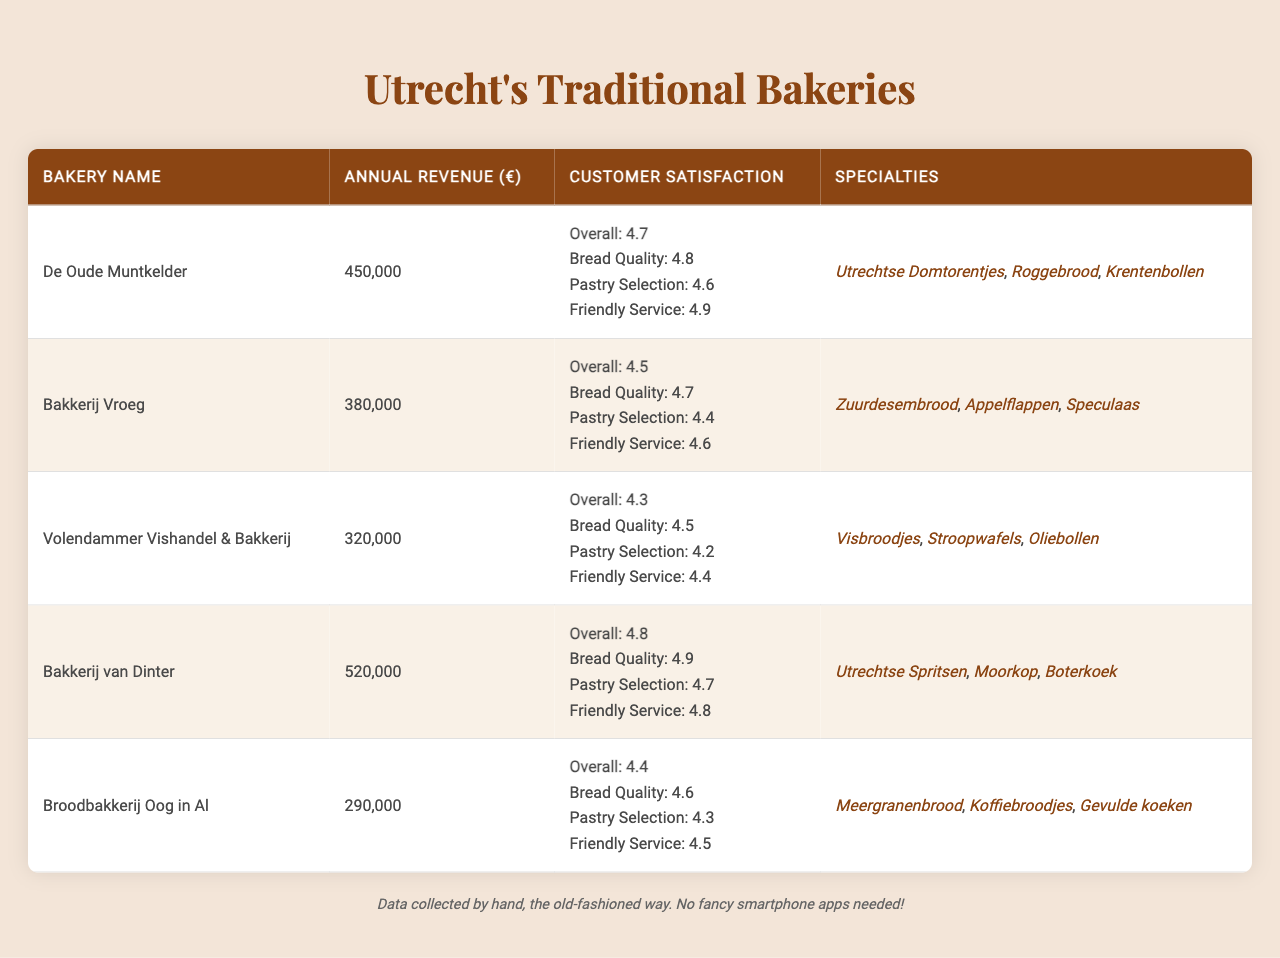What is the annual revenue of Bakkerij van Dinter? According to the table, the annual revenue listed for Bakkerij van Dinter is €520,000.
Answer: €520,000 Which bakery has the highest overall customer satisfaction rating? By comparing the overall ratings, Bakkerij van Dinter has the highest rating of 4.8, which is higher than the others.
Answer: Bakkerij van Dinter What is the average annual revenue of Utrecht's traditional bakeries? To find the average, sum the revenues: 450,000 + 380,000 + 320,000 + 520,000 + 290,000 = 1,960,000. Then divide by the number of bakeries (5): 1,960,000 / 5 = 392,000.
Answer: €392,000 Which bakery has the lowest customer satisfaction for pastry selection? By checking the pastry selection ratings, Volendammer Vishandel & Bakkerij is rated at 4.2, which is lower than the other bakeries.
Answer: Volendammer Vishandel & Bakkerij Is the annual revenue of Broodbakkerij Oog in Al greater than €300,000? The annual revenue for Broodbakkerij Oog in Al is €290,000, which is less than €300,000. Therefore, the statement is false.
Answer: No What is the combined annual revenue of De Oude Muntkelder and Bakkerij Vroeg? Adding their revenues: 450,000 (De Oude Muntkelder) + 380,000 (Bakkerij Vroeg) = 830,000 gives the combined total.
Answer: €830,000 How many bakeries offer Utrechtse specialties? From the data, De Oude Muntkelder and Bakkerij van Dinter both offer unique Utrecht specialties.
Answer: 2 Which bakery has the highest rating for friendly service? Bakkerij Vroeg has a friendly service rating of 4.6, while others have either the same or lower ratings. Bakkerij van Dinter has a slightly higher rating at 4.8.
Answer: Bakkerij van Dinter What percentage of bakeries has an overall satisfaction rating above 4.5? Four out of five bakeries have an overall rating above 4.5, providing a percentage of (4/5) * 100 = 80%.
Answer: 80% Which specialties are offered by the bakery with the lowest annual revenue? Broodbakkerij Oog in Al has the lowest revenue at €290,000 and offers specialties such as Meergranenbrood, Koffiebroodjes, and Gevulde koeken.
Answer: Meergranenbrood, Koffiebroodjes, Gevulde koeken 